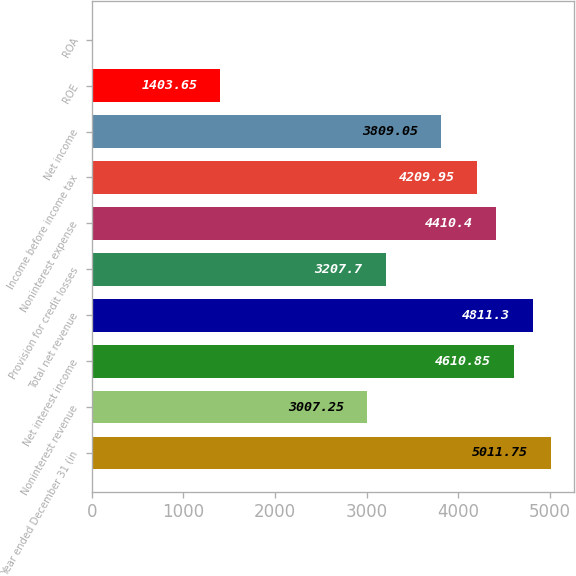Convert chart. <chart><loc_0><loc_0><loc_500><loc_500><bar_chart><fcel>Year ended December 31 (in<fcel>Noninterest revenue<fcel>Net interest income<fcel>Total net revenue<fcel>Provision for credit losses<fcel>Noninterest expense<fcel>Income before income tax<fcel>Net income<fcel>ROE<fcel>ROA<nl><fcel>5011.75<fcel>3007.25<fcel>4610.85<fcel>4811.3<fcel>3207.7<fcel>4410.4<fcel>4209.95<fcel>3809.05<fcel>1403.65<fcel>0.5<nl></chart> 